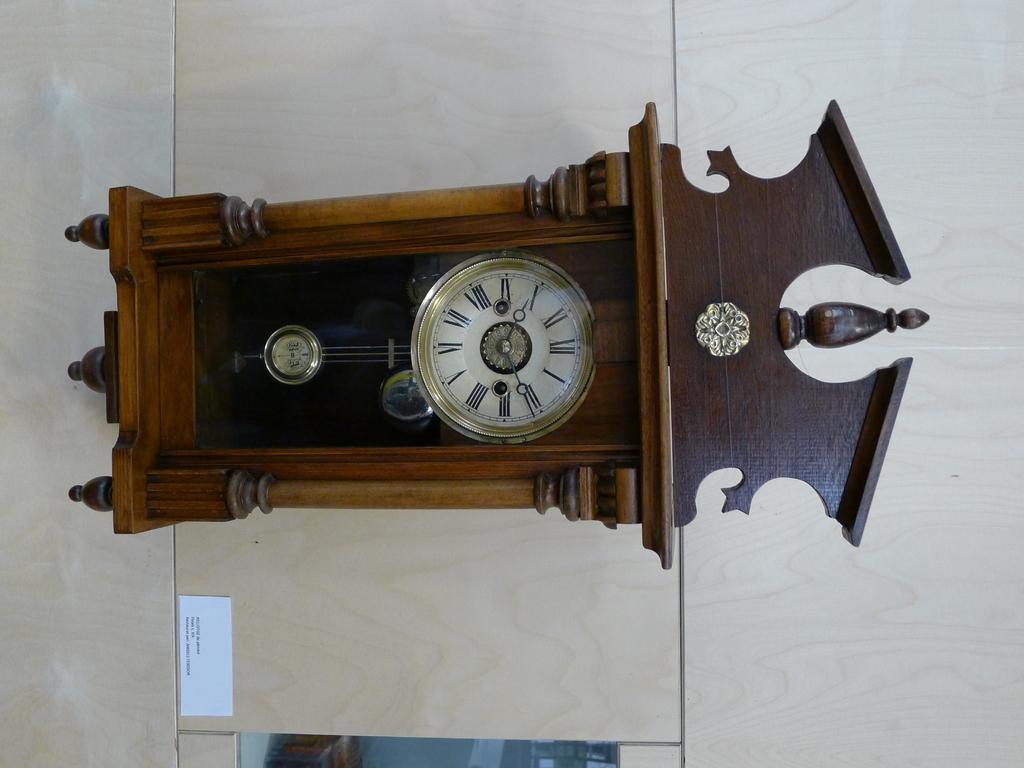What type of clock is visible in the image? There is a pendulum wall clock in the image. What is attached to the wooden wall in the image? There is a paper attached to a wooden wall in the image. What type of face can be seen on the paper in the image? There is no face present on the paper in the image. What musical instrument is being played in the image? There is no musical instrument being played in the image. 